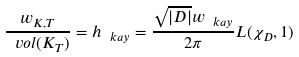<formula> <loc_0><loc_0><loc_500><loc_500>\frac { w _ { K , T } } { \ v o l ( K _ { T } ) } = h _ { \ k a y } = \frac { \sqrt { | D | } w _ { \ k a y } } { 2 \pi } L ( \chi _ { D } , 1 )</formula> 